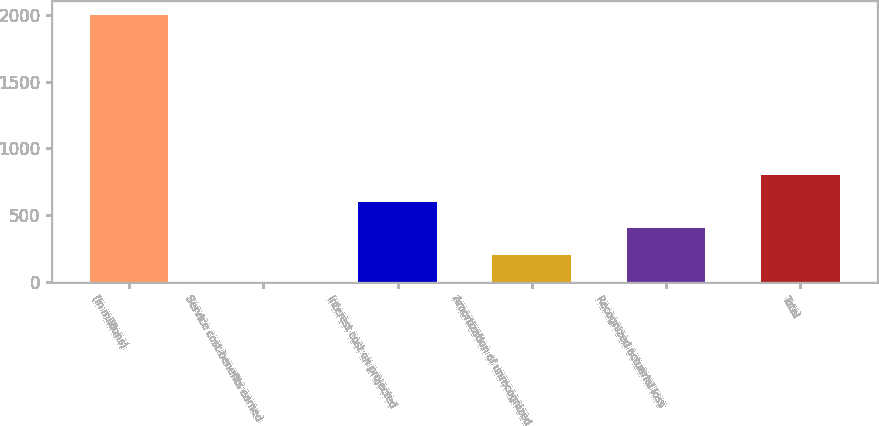Convert chart to OTSL. <chart><loc_0><loc_0><loc_500><loc_500><bar_chart><fcel>(In millions)<fcel>Service cost-benefits earned<fcel>Interest cost on projected<fcel>Amortization of unrecognized<fcel>Recognized actuarial loss<fcel>Total<nl><fcel>2001<fcel>0.7<fcel>600.79<fcel>200.73<fcel>400.76<fcel>800.82<nl></chart> 